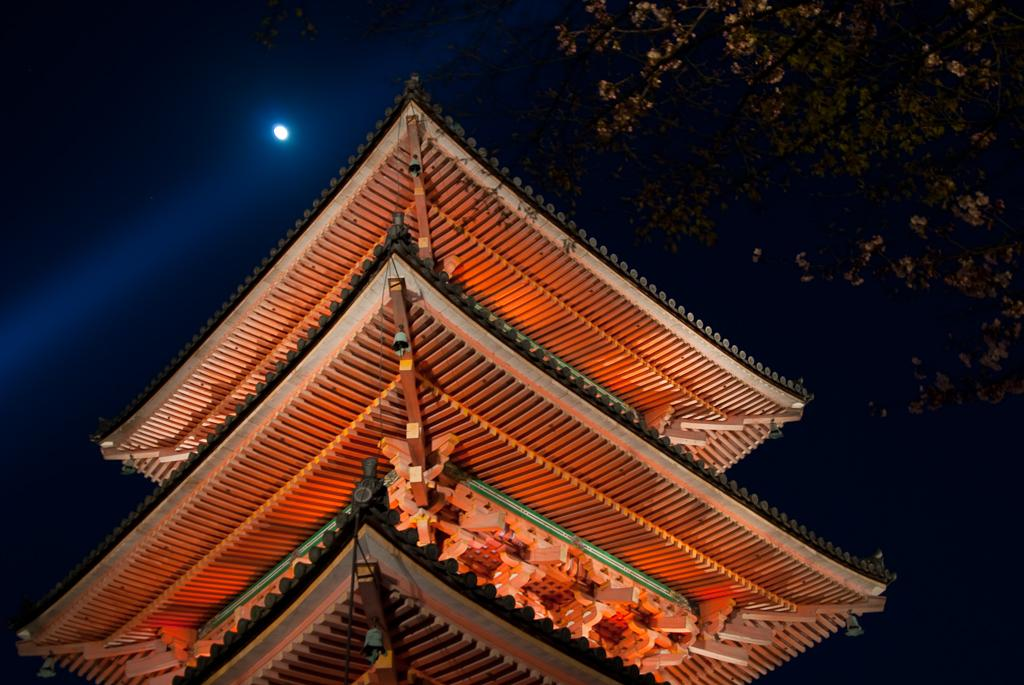What type of structure is present in the image? There is a building in the image. What feature can be seen on top of the building? The building has a roof. What material is present in the image? There are wood pieces in the image. What can be seen in the background of the image? There is a tree and the sky visible in the background of the image. What type of coat is the machine wearing in the image? There is no machine or coat present in the image. 